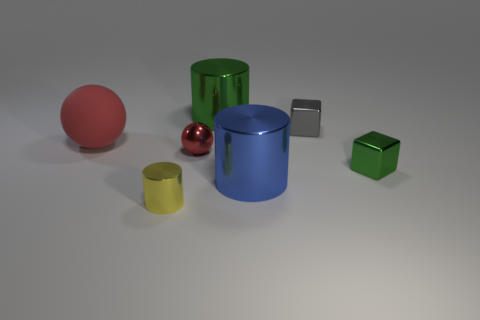Subtract all tiny cylinders. How many cylinders are left? 2 Subtract all blue cylinders. How many cylinders are left? 2 Add 1 tiny gray metal cubes. How many objects exist? 8 Subtract 2 blocks. How many blocks are left? 0 Subtract all green spheres. Subtract all green blocks. How many spheres are left? 2 Subtract all green blocks. How many blue spheres are left? 0 Subtract all metallic spheres. Subtract all tiny yellow cylinders. How many objects are left? 5 Add 4 red matte balls. How many red matte balls are left? 5 Add 1 yellow balls. How many yellow balls exist? 1 Subtract 0 green balls. How many objects are left? 7 